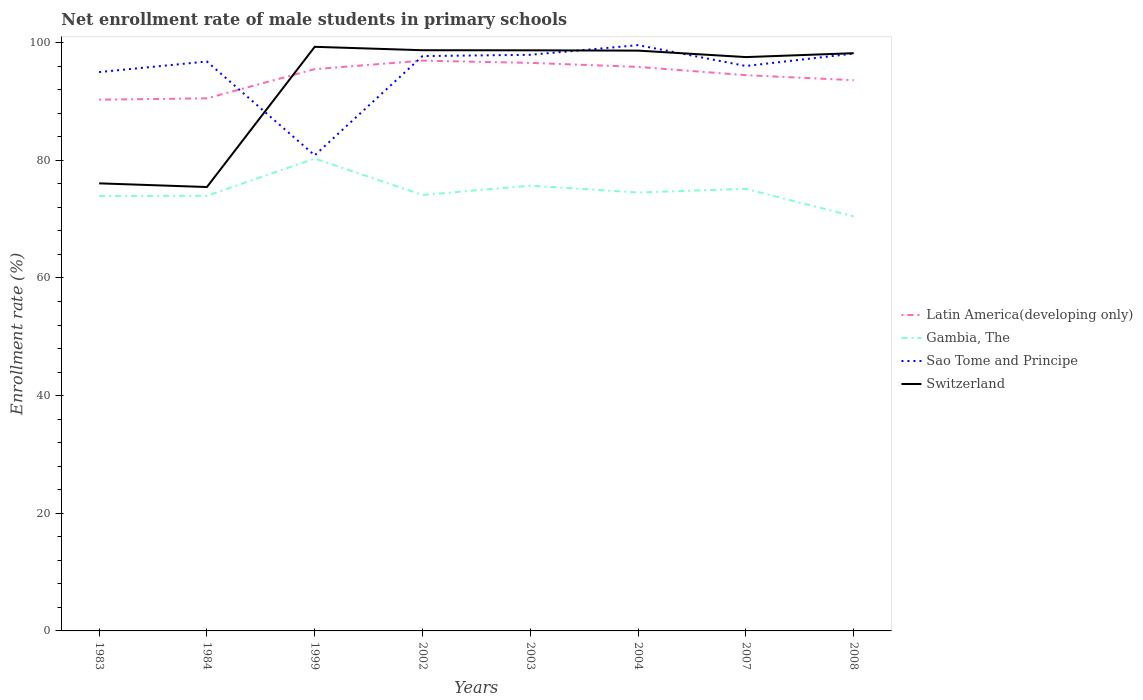Across all years, what is the maximum net enrollment rate of male students in primary schools in Switzerland?
Your response must be concise. 75.45. In which year was the net enrollment rate of male students in primary schools in Latin America(developing only) maximum?
Make the answer very short. 1983. What is the total net enrollment rate of male students in primary schools in Switzerland in the graph?
Give a very brief answer. 0.05. What is the difference between the highest and the second highest net enrollment rate of male students in primary schools in Gambia, The?
Ensure brevity in your answer.  9.83. Is the net enrollment rate of male students in primary schools in Gambia, The strictly greater than the net enrollment rate of male students in primary schools in Switzerland over the years?
Give a very brief answer. Yes. How many years are there in the graph?
Offer a very short reply. 8. Are the values on the major ticks of Y-axis written in scientific E-notation?
Ensure brevity in your answer.  No. How are the legend labels stacked?
Your answer should be compact. Vertical. What is the title of the graph?
Ensure brevity in your answer.  Net enrollment rate of male students in primary schools. What is the label or title of the Y-axis?
Offer a very short reply. Enrollment rate (%). What is the Enrollment rate (%) of Latin America(developing only) in 1983?
Your answer should be very brief. 90.3. What is the Enrollment rate (%) in Gambia, The in 1983?
Provide a short and direct response. 73.94. What is the Enrollment rate (%) in Sao Tome and Principe in 1983?
Provide a short and direct response. 94.99. What is the Enrollment rate (%) of Switzerland in 1983?
Your response must be concise. 76.08. What is the Enrollment rate (%) of Latin America(developing only) in 1984?
Offer a terse response. 90.53. What is the Enrollment rate (%) of Gambia, The in 1984?
Give a very brief answer. 73.97. What is the Enrollment rate (%) in Sao Tome and Principe in 1984?
Ensure brevity in your answer.  96.79. What is the Enrollment rate (%) of Switzerland in 1984?
Provide a succinct answer. 75.45. What is the Enrollment rate (%) in Latin America(developing only) in 1999?
Keep it short and to the point. 95.5. What is the Enrollment rate (%) of Gambia, The in 1999?
Your answer should be compact. 80.3. What is the Enrollment rate (%) of Sao Tome and Principe in 1999?
Offer a terse response. 80.84. What is the Enrollment rate (%) in Switzerland in 1999?
Provide a succinct answer. 99.29. What is the Enrollment rate (%) of Latin America(developing only) in 2002?
Keep it short and to the point. 96.94. What is the Enrollment rate (%) of Gambia, The in 2002?
Your answer should be very brief. 74.1. What is the Enrollment rate (%) in Sao Tome and Principe in 2002?
Offer a very short reply. 97.72. What is the Enrollment rate (%) of Switzerland in 2002?
Offer a terse response. 98.71. What is the Enrollment rate (%) of Latin America(developing only) in 2003?
Make the answer very short. 96.56. What is the Enrollment rate (%) of Gambia, The in 2003?
Your response must be concise. 75.69. What is the Enrollment rate (%) in Sao Tome and Principe in 2003?
Give a very brief answer. 97.93. What is the Enrollment rate (%) in Switzerland in 2003?
Offer a terse response. 98.69. What is the Enrollment rate (%) in Latin America(developing only) in 2004?
Provide a short and direct response. 95.88. What is the Enrollment rate (%) in Gambia, The in 2004?
Offer a very short reply. 74.53. What is the Enrollment rate (%) in Sao Tome and Principe in 2004?
Provide a short and direct response. 99.57. What is the Enrollment rate (%) of Switzerland in 2004?
Offer a very short reply. 98.64. What is the Enrollment rate (%) of Latin America(developing only) in 2007?
Provide a short and direct response. 94.47. What is the Enrollment rate (%) of Gambia, The in 2007?
Keep it short and to the point. 75.15. What is the Enrollment rate (%) of Sao Tome and Principe in 2007?
Provide a short and direct response. 96.03. What is the Enrollment rate (%) of Switzerland in 2007?
Offer a very short reply. 97.54. What is the Enrollment rate (%) of Latin America(developing only) in 2008?
Offer a terse response. 93.62. What is the Enrollment rate (%) of Gambia, The in 2008?
Offer a terse response. 70.47. What is the Enrollment rate (%) of Sao Tome and Principe in 2008?
Ensure brevity in your answer.  98.14. What is the Enrollment rate (%) of Switzerland in 2008?
Ensure brevity in your answer.  98.2. Across all years, what is the maximum Enrollment rate (%) of Latin America(developing only)?
Offer a very short reply. 96.94. Across all years, what is the maximum Enrollment rate (%) of Gambia, The?
Your response must be concise. 80.3. Across all years, what is the maximum Enrollment rate (%) in Sao Tome and Principe?
Ensure brevity in your answer.  99.57. Across all years, what is the maximum Enrollment rate (%) in Switzerland?
Offer a very short reply. 99.29. Across all years, what is the minimum Enrollment rate (%) of Latin America(developing only)?
Your answer should be very brief. 90.3. Across all years, what is the minimum Enrollment rate (%) of Gambia, The?
Your response must be concise. 70.47. Across all years, what is the minimum Enrollment rate (%) of Sao Tome and Principe?
Offer a terse response. 80.84. Across all years, what is the minimum Enrollment rate (%) of Switzerland?
Provide a succinct answer. 75.45. What is the total Enrollment rate (%) of Latin America(developing only) in the graph?
Make the answer very short. 753.78. What is the total Enrollment rate (%) in Gambia, The in the graph?
Your answer should be very brief. 598.14. What is the total Enrollment rate (%) in Sao Tome and Principe in the graph?
Provide a succinct answer. 762.01. What is the total Enrollment rate (%) of Switzerland in the graph?
Make the answer very short. 742.61. What is the difference between the Enrollment rate (%) of Latin America(developing only) in 1983 and that in 1984?
Give a very brief answer. -0.23. What is the difference between the Enrollment rate (%) of Gambia, The in 1983 and that in 1984?
Give a very brief answer. -0.03. What is the difference between the Enrollment rate (%) in Sao Tome and Principe in 1983 and that in 1984?
Give a very brief answer. -1.8. What is the difference between the Enrollment rate (%) of Switzerland in 1983 and that in 1984?
Your response must be concise. 0.63. What is the difference between the Enrollment rate (%) of Latin America(developing only) in 1983 and that in 1999?
Your response must be concise. -5.19. What is the difference between the Enrollment rate (%) in Gambia, The in 1983 and that in 1999?
Ensure brevity in your answer.  -6.36. What is the difference between the Enrollment rate (%) of Sao Tome and Principe in 1983 and that in 1999?
Your response must be concise. 14.15. What is the difference between the Enrollment rate (%) in Switzerland in 1983 and that in 1999?
Provide a succinct answer. -23.21. What is the difference between the Enrollment rate (%) of Latin America(developing only) in 1983 and that in 2002?
Ensure brevity in your answer.  -6.63. What is the difference between the Enrollment rate (%) in Gambia, The in 1983 and that in 2002?
Keep it short and to the point. -0.16. What is the difference between the Enrollment rate (%) of Sao Tome and Principe in 1983 and that in 2002?
Offer a very short reply. -2.72. What is the difference between the Enrollment rate (%) of Switzerland in 1983 and that in 2002?
Provide a succinct answer. -22.63. What is the difference between the Enrollment rate (%) of Latin America(developing only) in 1983 and that in 2003?
Ensure brevity in your answer.  -6.25. What is the difference between the Enrollment rate (%) of Gambia, The in 1983 and that in 2003?
Make the answer very short. -1.75. What is the difference between the Enrollment rate (%) of Sao Tome and Principe in 1983 and that in 2003?
Ensure brevity in your answer.  -2.94. What is the difference between the Enrollment rate (%) of Switzerland in 1983 and that in 2003?
Provide a succinct answer. -22.61. What is the difference between the Enrollment rate (%) of Latin America(developing only) in 1983 and that in 2004?
Offer a very short reply. -5.57. What is the difference between the Enrollment rate (%) in Gambia, The in 1983 and that in 2004?
Offer a terse response. -0.58. What is the difference between the Enrollment rate (%) of Sao Tome and Principe in 1983 and that in 2004?
Provide a short and direct response. -4.58. What is the difference between the Enrollment rate (%) in Switzerland in 1983 and that in 2004?
Give a very brief answer. -22.56. What is the difference between the Enrollment rate (%) of Latin America(developing only) in 1983 and that in 2007?
Offer a very short reply. -4.17. What is the difference between the Enrollment rate (%) in Gambia, The in 1983 and that in 2007?
Provide a succinct answer. -1.21. What is the difference between the Enrollment rate (%) of Sao Tome and Principe in 1983 and that in 2007?
Offer a very short reply. -1.04. What is the difference between the Enrollment rate (%) of Switzerland in 1983 and that in 2007?
Keep it short and to the point. -21.46. What is the difference between the Enrollment rate (%) in Latin America(developing only) in 1983 and that in 2008?
Provide a succinct answer. -3.31. What is the difference between the Enrollment rate (%) in Gambia, The in 1983 and that in 2008?
Make the answer very short. 3.47. What is the difference between the Enrollment rate (%) in Sao Tome and Principe in 1983 and that in 2008?
Your response must be concise. -3.14. What is the difference between the Enrollment rate (%) in Switzerland in 1983 and that in 2008?
Ensure brevity in your answer.  -22.12. What is the difference between the Enrollment rate (%) in Latin America(developing only) in 1984 and that in 1999?
Your answer should be very brief. -4.96. What is the difference between the Enrollment rate (%) of Gambia, The in 1984 and that in 1999?
Your response must be concise. -6.33. What is the difference between the Enrollment rate (%) of Sao Tome and Principe in 1984 and that in 1999?
Give a very brief answer. 15.95. What is the difference between the Enrollment rate (%) in Switzerland in 1984 and that in 1999?
Give a very brief answer. -23.84. What is the difference between the Enrollment rate (%) of Latin America(developing only) in 1984 and that in 2002?
Give a very brief answer. -6.41. What is the difference between the Enrollment rate (%) in Gambia, The in 1984 and that in 2002?
Keep it short and to the point. -0.13. What is the difference between the Enrollment rate (%) in Sao Tome and Principe in 1984 and that in 2002?
Ensure brevity in your answer.  -0.92. What is the difference between the Enrollment rate (%) in Switzerland in 1984 and that in 2002?
Ensure brevity in your answer.  -23.26. What is the difference between the Enrollment rate (%) of Latin America(developing only) in 1984 and that in 2003?
Keep it short and to the point. -6.03. What is the difference between the Enrollment rate (%) in Gambia, The in 1984 and that in 2003?
Give a very brief answer. -1.72. What is the difference between the Enrollment rate (%) in Sao Tome and Principe in 1984 and that in 2003?
Your answer should be very brief. -1.14. What is the difference between the Enrollment rate (%) of Switzerland in 1984 and that in 2003?
Your answer should be compact. -23.24. What is the difference between the Enrollment rate (%) of Latin America(developing only) in 1984 and that in 2004?
Your answer should be compact. -5.34. What is the difference between the Enrollment rate (%) of Gambia, The in 1984 and that in 2004?
Your response must be concise. -0.56. What is the difference between the Enrollment rate (%) of Sao Tome and Principe in 1984 and that in 2004?
Provide a succinct answer. -2.78. What is the difference between the Enrollment rate (%) of Switzerland in 1984 and that in 2004?
Provide a succinct answer. -23.19. What is the difference between the Enrollment rate (%) of Latin America(developing only) in 1984 and that in 2007?
Make the answer very short. -3.94. What is the difference between the Enrollment rate (%) in Gambia, The in 1984 and that in 2007?
Offer a very short reply. -1.18. What is the difference between the Enrollment rate (%) of Sao Tome and Principe in 1984 and that in 2007?
Ensure brevity in your answer.  0.76. What is the difference between the Enrollment rate (%) of Switzerland in 1984 and that in 2007?
Provide a short and direct response. -22.09. What is the difference between the Enrollment rate (%) of Latin America(developing only) in 1984 and that in 2008?
Ensure brevity in your answer.  -3.08. What is the difference between the Enrollment rate (%) in Gambia, The in 1984 and that in 2008?
Ensure brevity in your answer.  3.49. What is the difference between the Enrollment rate (%) in Sao Tome and Principe in 1984 and that in 2008?
Your response must be concise. -1.35. What is the difference between the Enrollment rate (%) of Switzerland in 1984 and that in 2008?
Keep it short and to the point. -22.75. What is the difference between the Enrollment rate (%) of Latin America(developing only) in 1999 and that in 2002?
Provide a short and direct response. -1.44. What is the difference between the Enrollment rate (%) of Gambia, The in 1999 and that in 2002?
Offer a terse response. 6.2. What is the difference between the Enrollment rate (%) in Sao Tome and Principe in 1999 and that in 2002?
Your response must be concise. -16.88. What is the difference between the Enrollment rate (%) of Switzerland in 1999 and that in 2002?
Make the answer very short. 0.58. What is the difference between the Enrollment rate (%) of Latin America(developing only) in 1999 and that in 2003?
Provide a succinct answer. -1.06. What is the difference between the Enrollment rate (%) of Gambia, The in 1999 and that in 2003?
Your answer should be very brief. 4.61. What is the difference between the Enrollment rate (%) in Sao Tome and Principe in 1999 and that in 2003?
Your answer should be very brief. -17.09. What is the difference between the Enrollment rate (%) in Switzerland in 1999 and that in 2003?
Keep it short and to the point. 0.59. What is the difference between the Enrollment rate (%) in Latin America(developing only) in 1999 and that in 2004?
Provide a succinct answer. -0.38. What is the difference between the Enrollment rate (%) of Gambia, The in 1999 and that in 2004?
Make the answer very short. 5.77. What is the difference between the Enrollment rate (%) of Sao Tome and Principe in 1999 and that in 2004?
Provide a succinct answer. -18.74. What is the difference between the Enrollment rate (%) in Switzerland in 1999 and that in 2004?
Provide a short and direct response. 0.65. What is the difference between the Enrollment rate (%) of Latin America(developing only) in 1999 and that in 2007?
Offer a very short reply. 1.03. What is the difference between the Enrollment rate (%) in Gambia, The in 1999 and that in 2007?
Ensure brevity in your answer.  5.15. What is the difference between the Enrollment rate (%) in Sao Tome and Principe in 1999 and that in 2007?
Give a very brief answer. -15.19. What is the difference between the Enrollment rate (%) of Switzerland in 1999 and that in 2007?
Provide a succinct answer. 1.75. What is the difference between the Enrollment rate (%) in Latin America(developing only) in 1999 and that in 2008?
Ensure brevity in your answer.  1.88. What is the difference between the Enrollment rate (%) in Gambia, The in 1999 and that in 2008?
Your answer should be compact. 9.83. What is the difference between the Enrollment rate (%) in Sao Tome and Principe in 1999 and that in 2008?
Ensure brevity in your answer.  -17.3. What is the difference between the Enrollment rate (%) of Switzerland in 1999 and that in 2008?
Provide a succinct answer. 1.08. What is the difference between the Enrollment rate (%) of Latin America(developing only) in 2002 and that in 2003?
Your answer should be very brief. 0.38. What is the difference between the Enrollment rate (%) in Gambia, The in 2002 and that in 2003?
Your answer should be very brief. -1.59. What is the difference between the Enrollment rate (%) in Sao Tome and Principe in 2002 and that in 2003?
Keep it short and to the point. -0.21. What is the difference between the Enrollment rate (%) in Switzerland in 2002 and that in 2003?
Make the answer very short. 0.02. What is the difference between the Enrollment rate (%) in Latin America(developing only) in 2002 and that in 2004?
Your answer should be very brief. 1.06. What is the difference between the Enrollment rate (%) in Gambia, The in 2002 and that in 2004?
Keep it short and to the point. -0.42. What is the difference between the Enrollment rate (%) in Sao Tome and Principe in 2002 and that in 2004?
Provide a succinct answer. -1.86. What is the difference between the Enrollment rate (%) in Switzerland in 2002 and that in 2004?
Your response must be concise. 0.07. What is the difference between the Enrollment rate (%) in Latin America(developing only) in 2002 and that in 2007?
Your answer should be very brief. 2.47. What is the difference between the Enrollment rate (%) in Gambia, The in 2002 and that in 2007?
Provide a short and direct response. -1.04. What is the difference between the Enrollment rate (%) in Sao Tome and Principe in 2002 and that in 2007?
Offer a very short reply. 1.69. What is the difference between the Enrollment rate (%) of Switzerland in 2002 and that in 2007?
Give a very brief answer. 1.17. What is the difference between the Enrollment rate (%) in Latin America(developing only) in 2002 and that in 2008?
Make the answer very short. 3.32. What is the difference between the Enrollment rate (%) of Gambia, The in 2002 and that in 2008?
Make the answer very short. 3.63. What is the difference between the Enrollment rate (%) in Sao Tome and Principe in 2002 and that in 2008?
Your response must be concise. -0.42. What is the difference between the Enrollment rate (%) of Switzerland in 2002 and that in 2008?
Your answer should be compact. 0.51. What is the difference between the Enrollment rate (%) of Latin America(developing only) in 2003 and that in 2004?
Provide a short and direct response. 0.68. What is the difference between the Enrollment rate (%) of Gambia, The in 2003 and that in 2004?
Your answer should be very brief. 1.16. What is the difference between the Enrollment rate (%) of Sao Tome and Principe in 2003 and that in 2004?
Your answer should be compact. -1.64. What is the difference between the Enrollment rate (%) of Switzerland in 2003 and that in 2004?
Your answer should be compact. 0.05. What is the difference between the Enrollment rate (%) of Latin America(developing only) in 2003 and that in 2007?
Offer a very short reply. 2.09. What is the difference between the Enrollment rate (%) in Gambia, The in 2003 and that in 2007?
Your answer should be compact. 0.54. What is the difference between the Enrollment rate (%) of Sao Tome and Principe in 2003 and that in 2007?
Your response must be concise. 1.9. What is the difference between the Enrollment rate (%) in Switzerland in 2003 and that in 2007?
Ensure brevity in your answer.  1.15. What is the difference between the Enrollment rate (%) of Latin America(developing only) in 2003 and that in 2008?
Offer a very short reply. 2.94. What is the difference between the Enrollment rate (%) of Gambia, The in 2003 and that in 2008?
Give a very brief answer. 5.22. What is the difference between the Enrollment rate (%) of Sao Tome and Principe in 2003 and that in 2008?
Make the answer very short. -0.21. What is the difference between the Enrollment rate (%) in Switzerland in 2003 and that in 2008?
Your answer should be compact. 0.49. What is the difference between the Enrollment rate (%) of Latin America(developing only) in 2004 and that in 2007?
Provide a short and direct response. 1.41. What is the difference between the Enrollment rate (%) of Gambia, The in 2004 and that in 2007?
Ensure brevity in your answer.  -0.62. What is the difference between the Enrollment rate (%) in Sao Tome and Principe in 2004 and that in 2007?
Make the answer very short. 3.54. What is the difference between the Enrollment rate (%) in Switzerland in 2004 and that in 2007?
Provide a succinct answer. 1.1. What is the difference between the Enrollment rate (%) in Latin America(developing only) in 2004 and that in 2008?
Keep it short and to the point. 2.26. What is the difference between the Enrollment rate (%) in Gambia, The in 2004 and that in 2008?
Ensure brevity in your answer.  4.05. What is the difference between the Enrollment rate (%) in Sao Tome and Principe in 2004 and that in 2008?
Offer a very short reply. 1.44. What is the difference between the Enrollment rate (%) in Switzerland in 2004 and that in 2008?
Ensure brevity in your answer.  0.44. What is the difference between the Enrollment rate (%) in Latin America(developing only) in 2007 and that in 2008?
Your answer should be very brief. 0.85. What is the difference between the Enrollment rate (%) in Gambia, The in 2007 and that in 2008?
Ensure brevity in your answer.  4.67. What is the difference between the Enrollment rate (%) in Sao Tome and Principe in 2007 and that in 2008?
Make the answer very short. -2.11. What is the difference between the Enrollment rate (%) of Switzerland in 2007 and that in 2008?
Provide a short and direct response. -0.66. What is the difference between the Enrollment rate (%) in Latin America(developing only) in 1983 and the Enrollment rate (%) in Gambia, The in 1984?
Give a very brief answer. 16.34. What is the difference between the Enrollment rate (%) of Latin America(developing only) in 1983 and the Enrollment rate (%) of Sao Tome and Principe in 1984?
Keep it short and to the point. -6.49. What is the difference between the Enrollment rate (%) in Latin America(developing only) in 1983 and the Enrollment rate (%) in Switzerland in 1984?
Keep it short and to the point. 14.85. What is the difference between the Enrollment rate (%) of Gambia, The in 1983 and the Enrollment rate (%) of Sao Tome and Principe in 1984?
Provide a short and direct response. -22.85. What is the difference between the Enrollment rate (%) of Gambia, The in 1983 and the Enrollment rate (%) of Switzerland in 1984?
Your answer should be very brief. -1.51. What is the difference between the Enrollment rate (%) in Sao Tome and Principe in 1983 and the Enrollment rate (%) in Switzerland in 1984?
Offer a very short reply. 19.54. What is the difference between the Enrollment rate (%) in Latin America(developing only) in 1983 and the Enrollment rate (%) in Gambia, The in 1999?
Offer a very short reply. 10. What is the difference between the Enrollment rate (%) in Latin America(developing only) in 1983 and the Enrollment rate (%) in Sao Tome and Principe in 1999?
Offer a very short reply. 9.46. What is the difference between the Enrollment rate (%) of Latin America(developing only) in 1983 and the Enrollment rate (%) of Switzerland in 1999?
Your answer should be very brief. -8.99. What is the difference between the Enrollment rate (%) of Gambia, The in 1983 and the Enrollment rate (%) of Sao Tome and Principe in 1999?
Offer a very short reply. -6.9. What is the difference between the Enrollment rate (%) of Gambia, The in 1983 and the Enrollment rate (%) of Switzerland in 1999?
Your response must be concise. -25.35. What is the difference between the Enrollment rate (%) in Sao Tome and Principe in 1983 and the Enrollment rate (%) in Switzerland in 1999?
Offer a very short reply. -4.3. What is the difference between the Enrollment rate (%) in Latin America(developing only) in 1983 and the Enrollment rate (%) in Gambia, The in 2002?
Your answer should be compact. 16.2. What is the difference between the Enrollment rate (%) in Latin America(developing only) in 1983 and the Enrollment rate (%) in Sao Tome and Principe in 2002?
Your response must be concise. -7.41. What is the difference between the Enrollment rate (%) of Latin America(developing only) in 1983 and the Enrollment rate (%) of Switzerland in 2002?
Provide a short and direct response. -8.41. What is the difference between the Enrollment rate (%) in Gambia, The in 1983 and the Enrollment rate (%) in Sao Tome and Principe in 2002?
Ensure brevity in your answer.  -23.78. What is the difference between the Enrollment rate (%) in Gambia, The in 1983 and the Enrollment rate (%) in Switzerland in 2002?
Provide a short and direct response. -24.77. What is the difference between the Enrollment rate (%) of Sao Tome and Principe in 1983 and the Enrollment rate (%) of Switzerland in 2002?
Your answer should be very brief. -3.72. What is the difference between the Enrollment rate (%) of Latin America(developing only) in 1983 and the Enrollment rate (%) of Gambia, The in 2003?
Your answer should be compact. 14.61. What is the difference between the Enrollment rate (%) in Latin America(developing only) in 1983 and the Enrollment rate (%) in Sao Tome and Principe in 2003?
Your answer should be very brief. -7.63. What is the difference between the Enrollment rate (%) of Latin America(developing only) in 1983 and the Enrollment rate (%) of Switzerland in 2003?
Offer a terse response. -8.39. What is the difference between the Enrollment rate (%) in Gambia, The in 1983 and the Enrollment rate (%) in Sao Tome and Principe in 2003?
Your answer should be very brief. -23.99. What is the difference between the Enrollment rate (%) of Gambia, The in 1983 and the Enrollment rate (%) of Switzerland in 2003?
Your answer should be very brief. -24.75. What is the difference between the Enrollment rate (%) in Sao Tome and Principe in 1983 and the Enrollment rate (%) in Switzerland in 2003?
Your answer should be very brief. -3.7. What is the difference between the Enrollment rate (%) of Latin America(developing only) in 1983 and the Enrollment rate (%) of Gambia, The in 2004?
Your answer should be very brief. 15.78. What is the difference between the Enrollment rate (%) of Latin America(developing only) in 1983 and the Enrollment rate (%) of Sao Tome and Principe in 2004?
Offer a terse response. -9.27. What is the difference between the Enrollment rate (%) in Latin America(developing only) in 1983 and the Enrollment rate (%) in Switzerland in 2004?
Offer a terse response. -8.34. What is the difference between the Enrollment rate (%) of Gambia, The in 1983 and the Enrollment rate (%) of Sao Tome and Principe in 2004?
Keep it short and to the point. -25.63. What is the difference between the Enrollment rate (%) in Gambia, The in 1983 and the Enrollment rate (%) in Switzerland in 2004?
Ensure brevity in your answer.  -24.7. What is the difference between the Enrollment rate (%) in Sao Tome and Principe in 1983 and the Enrollment rate (%) in Switzerland in 2004?
Keep it short and to the point. -3.65. What is the difference between the Enrollment rate (%) of Latin America(developing only) in 1983 and the Enrollment rate (%) of Gambia, The in 2007?
Offer a terse response. 15.16. What is the difference between the Enrollment rate (%) of Latin America(developing only) in 1983 and the Enrollment rate (%) of Sao Tome and Principe in 2007?
Make the answer very short. -5.73. What is the difference between the Enrollment rate (%) in Latin America(developing only) in 1983 and the Enrollment rate (%) in Switzerland in 2007?
Your response must be concise. -7.24. What is the difference between the Enrollment rate (%) of Gambia, The in 1983 and the Enrollment rate (%) of Sao Tome and Principe in 2007?
Provide a short and direct response. -22.09. What is the difference between the Enrollment rate (%) of Gambia, The in 1983 and the Enrollment rate (%) of Switzerland in 2007?
Your response must be concise. -23.6. What is the difference between the Enrollment rate (%) in Sao Tome and Principe in 1983 and the Enrollment rate (%) in Switzerland in 2007?
Offer a terse response. -2.55. What is the difference between the Enrollment rate (%) in Latin America(developing only) in 1983 and the Enrollment rate (%) in Gambia, The in 2008?
Provide a succinct answer. 19.83. What is the difference between the Enrollment rate (%) of Latin America(developing only) in 1983 and the Enrollment rate (%) of Sao Tome and Principe in 2008?
Offer a terse response. -7.83. What is the difference between the Enrollment rate (%) of Latin America(developing only) in 1983 and the Enrollment rate (%) of Switzerland in 2008?
Your answer should be compact. -7.9. What is the difference between the Enrollment rate (%) of Gambia, The in 1983 and the Enrollment rate (%) of Sao Tome and Principe in 2008?
Your answer should be very brief. -24.2. What is the difference between the Enrollment rate (%) in Gambia, The in 1983 and the Enrollment rate (%) in Switzerland in 2008?
Your response must be concise. -24.26. What is the difference between the Enrollment rate (%) in Sao Tome and Principe in 1983 and the Enrollment rate (%) in Switzerland in 2008?
Make the answer very short. -3.21. What is the difference between the Enrollment rate (%) in Latin America(developing only) in 1984 and the Enrollment rate (%) in Gambia, The in 1999?
Your response must be concise. 10.23. What is the difference between the Enrollment rate (%) in Latin America(developing only) in 1984 and the Enrollment rate (%) in Sao Tome and Principe in 1999?
Your answer should be compact. 9.69. What is the difference between the Enrollment rate (%) of Latin America(developing only) in 1984 and the Enrollment rate (%) of Switzerland in 1999?
Make the answer very short. -8.76. What is the difference between the Enrollment rate (%) in Gambia, The in 1984 and the Enrollment rate (%) in Sao Tome and Principe in 1999?
Make the answer very short. -6.87. What is the difference between the Enrollment rate (%) of Gambia, The in 1984 and the Enrollment rate (%) of Switzerland in 1999?
Offer a very short reply. -25.32. What is the difference between the Enrollment rate (%) in Sao Tome and Principe in 1984 and the Enrollment rate (%) in Switzerland in 1999?
Provide a succinct answer. -2.5. What is the difference between the Enrollment rate (%) in Latin America(developing only) in 1984 and the Enrollment rate (%) in Gambia, The in 2002?
Your answer should be compact. 16.43. What is the difference between the Enrollment rate (%) in Latin America(developing only) in 1984 and the Enrollment rate (%) in Sao Tome and Principe in 2002?
Offer a very short reply. -7.19. What is the difference between the Enrollment rate (%) in Latin America(developing only) in 1984 and the Enrollment rate (%) in Switzerland in 2002?
Your response must be concise. -8.18. What is the difference between the Enrollment rate (%) of Gambia, The in 1984 and the Enrollment rate (%) of Sao Tome and Principe in 2002?
Make the answer very short. -23.75. What is the difference between the Enrollment rate (%) of Gambia, The in 1984 and the Enrollment rate (%) of Switzerland in 2002?
Make the answer very short. -24.74. What is the difference between the Enrollment rate (%) in Sao Tome and Principe in 1984 and the Enrollment rate (%) in Switzerland in 2002?
Give a very brief answer. -1.92. What is the difference between the Enrollment rate (%) of Latin America(developing only) in 1984 and the Enrollment rate (%) of Gambia, The in 2003?
Give a very brief answer. 14.84. What is the difference between the Enrollment rate (%) in Latin America(developing only) in 1984 and the Enrollment rate (%) in Sao Tome and Principe in 2003?
Provide a short and direct response. -7.4. What is the difference between the Enrollment rate (%) of Latin America(developing only) in 1984 and the Enrollment rate (%) of Switzerland in 2003?
Offer a terse response. -8.16. What is the difference between the Enrollment rate (%) of Gambia, The in 1984 and the Enrollment rate (%) of Sao Tome and Principe in 2003?
Offer a terse response. -23.96. What is the difference between the Enrollment rate (%) in Gambia, The in 1984 and the Enrollment rate (%) in Switzerland in 2003?
Offer a very short reply. -24.73. What is the difference between the Enrollment rate (%) in Sao Tome and Principe in 1984 and the Enrollment rate (%) in Switzerland in 2003?
Ensure brevity in your answer.  -1.9. What is the difference between the Enrollment rate (%) in Latin America(developing only) in 1984 and the Enrollment rate (%) in Gambia, The in 2004?
Your answer should be very brief. 16.01. What is the difference between the Enrollment rate (%) of Latin America(developing only) in 1984 and the Enrollment rate (%) of Sao Tome and Principe in 2004?
Give a very brief answer. -9.04. What is the difference between the Enrollment rate (%) in Latin America(developing only) in 1984 and the Enrollment rate (%) in Switzerland in 2004?
Make the answer very short. -8.11. What is the difference between the Enrollment rate (%) in Gambia, The in 1984 and the Enrollment rate (%) in Sao Tome and Principe in 2004?
Your answer should be compact. -25.61. What is the difference between the Enrollment rate (%) of Gambia, The in 1984 and the Enrollment rate (%) of Switzerland in 2004?
Your answer should be very brief. -24.67. What is the difference between the Enrollment rate (%) in Sao Tome and Principe in 1984 and the Enrollment rate (%) in Switzerland in 2004?
Ensure brevity in your answer.  -1.85. What is the difference between the Enrollment rate (%) of Latin America(developing only) in 1984 and the Enrollment rate (%) of Gambia, The in 2007?
Keep it short and to the point. 15.38. What is the difference between the Enrollment rate (%) in Latin America(developing only) in 1984 and the Enrollment rate (%) in Sao Tome and Principe in 2007?
Offer a very short reply. -5.5. What is the difference between the Enrollment rate (%) in Latin America(developing only) in 1984 and the Enrollment rate (%) in Switzerland in 2007?
Offer a very short reply. -7.01. What is the difference between the Enrollment rate (%) of Gambia, The in 1984 and the Enrollment rate (%) of Sao Tome and Principe in 2007?
Keep it short and to the point. -22.06. What is the difference between the Enrollment rate (%) of Gambia, The in 1984 and the Enrollment rate (%) of Switzerland in 2007?
Give a very brief answer. -23.58. What is the difference between the Enrollment rate (%) of Sao Tome and Principe in 1984 and the Enrollment rate (%) of Switzerland in 2007?
Your response must be concise. -0.75. What is the difference between the Enrollment rate (%) in Latin America(developing only) in 1984 and the Enrollment rate (%) in Gambia, The in 2008?
Give a very brief answer. 20.06. What is the difference between the Enrollment rate (%) of Latin America(developing only) in 1984 and the Enrollment rate (%) of Sao Tome and Principe in 2008?
Make the answer very short. -7.61. What is the difference between the Enrollment rate (%) in Latin America(developing only) in 1984 and the Enrollment rate (%) in Switzerland in 2008?
Give a very brief answer. -7.67. What is the difference between the Enrollment rate (%) of Gambia, The in 1984 and the Enrollment rate (%) of Sao Tome and Principe in 2008?
Keep it short and to the point. -24.17. What is the difference between the Enrollment rate (%) in Gambia, The in 1984 and the Enrollment rate (%) in Switzerland in 2008?
Keep it short and to the point. -24.24. What is the difference between the Enrollment rate (%) in Sao Tome and Principe in 1984 and the Enrollment rate (%) in Switzerland in 2008?
Your answer should be compact. -1.41. What is the difference between the Enrollment rate (%) in Latin America(developing only) in 1999 and the Enrollment rate (%) in Gambia, The in 2002?
Offer a terse response. 21.39. What is the difference between the Enrollment rate (%) in Latin America(developing only) in 1999 and the Enrollment rate (%) in Sao Tome and Principe in 2002?
Your response must be concise. -2.22. What is the difference between the Enrollment rate (%) of Latin America(developing only) in 1999 and the Enrollment rate (%) of Switzerland in 2002?
Provide a short and direct response. -3.22. What is the difference between the Enrollment rate (%) in Gambia, The in 1999 and the Enrollment rate (%) in Sao Tome and Principe in 2002?
Offer a very short reply. -17.42. What is the difference between the Enrollment rate (%) of Gambia, The in 1999 and the Enrollment rate (%) of Switzerland in 2002?
Your answer should be compact. -18.41. What is the difference between the Enrollment rate (%) in Sao Tome and Principe in 1999 and the Enrollment rate (%) in Switzerland in 2002?
Your response must be concise. -17.87. What is the difference between the Enrollment rate (%) of Latin America(developing only) in 1999 and the Enrollment rate (%) of Gambia, The in 2003?
Your response must be concise. 19.8. What is the difference between the Enrollment rate (%) of Latin America(developing only) in 1999 and the Enrollment rate (%) of Sao Tome and Principe in 2003?
Provide a succinct answer. -2.44. What is the difference between the Enrollment rate (%) of Latin America(developing only) in 1999 and the Enrollment rate (%) of Switzerland in 2003?
Offer a terse response. -3.2. What is the difference between the Enrollment rate (%) of Gambia, The in 1999 and the Enrollment rate (%) of Sao Tome and Principe in 2003?
Your answer should be very brief. -17.63. What is the difference between the Enrollment rate (%) in Gambia, The in 1999 and the Enrollment rate (%) in Switzerland in 2003?
Provide a succinct answer. -18.39. What is the difference between the Enrollment rate (%) in Sao Tome and Principe in 1999 and the Enrollment rate (%) in Switzerland in 2003?
Your answer should be very brief. -17.86. What is the difference between the Enrollment rate (%) of Latin America(developing only) in 1999 and the Enrollment rate (%) of Gambia, The in 2004?
Make the answer very short. 20.97. What is the difference between the Enrollment rate (%) of Latin America(developing only) in 1999 and the Enrollment rate (%) of Sao Tome and Principe in 2004?
Keep it short and to the point. -4.08. What is the difference between the Enrollment rate (%) of Latin America(developing only) in 1999 and the Enrollment rate (%) of Switzerland in 2004?
Your response must be concise. -3.15. What is the difference between the Enrollment rate (%) of Gambia, The in 1999 and the Enrollment rate (%) of Sao Tome and Principe in 2004?
Ensure brevity in your answer.  -19.27. What is the difference between the Enrollment rate (%) in Gambia, The in 1999 and the Enrollment rate (%) in Switzerland in 2004?
Offer a terse response. -18.34. What is the difference between the Enrollment rate (%) in Sao Tome and Principe in 1999 and the Enrollment rate (%) in Switzerland in 2004?
Offer a terse response. -17.8. What is the difference between the Enrollment rate (%) of Latin America(developing only) in 1999 and the Enrollment rate (%) of Gambia, The in 2007?
Offer a terse response. 20.35. What is the difference between the Enrollment rate (%) of Latin America(developing only) in 1999 and the Enrollment rate (%) of Sao Tome and Principe in 2007?
Ensure brevity in your answer.  -0.53. What is the difference between the Enrollment rate (%) of Latin America(developing only) in 1999 and the Enrollment rate (%) of Switzerland in 2007?
Make the answer very short. -2.05. What is the difference between the Enrollment rate (%) in Gambia, The in 1999 and the Enrollment rate (%) in Sao Tome and Principe in 2007?
Offer a very short reply. -15.73. What is the difference between the Enrollment rate (%) of Gambia, The in 1999 and the Enrollment rate (%) of Switzerland in 2007?
Your response must be concise. -17.24. What is the difference between the Enrollment rate (%) in Sao Tome and Principe in 1999 and the Enrollment rate (%) in Switzerland in 2007?
Provide a succinct answer. -16.7. What is the difference between the Enrollment rate (%) in Latin America(developing only) in 1999 and the Enrollment rate (%) in Gambia, The in 2008?
Your answer should be very brief. 25.02. What is the difference between the Enrollment rate (%) of Latin America(developing only) in 1999 and the Enrollment rate (%) of Sao Tome and Principe in 2008?
Offer a very short reply. -2.64. What is the difference between the Enrollment rate (%) of Latin America(developing only) in 1999 and the Enrollment rate (%) of Switzerland in 2008?
Provide a short and direct response. -2.71. What is the difference between the Enrollment rate (%) of Gambia, The in 1999 and the Enrollment rate (%) of Sao Tome and Principe in 2008?
Your response must be concise. -17.84. What is the difference between the Enrollment rate (%) in Gambia, The in 1999 and the Enrollment rate (%) in Switzerland in 2008?
Give a very brief answer. -17.91. What is the difference between the Enrollment rate (%) of Sao Tome and Principe in 1999 and the Enrollment rate (%) of Switzerland in 2008?
Offer a terse response. -17.37. What is the difference between the Enrollment rate (%) in Latin America(developing only) in 2002 and the Enrollment rate (%) in Gambia, The in 2003?
Offer a very short reply. 21.25. What is the difference between the Enrollment rate (%) of Latin America(developing only) in 2002 and the Enrollment rate (%) of Sao Tome and Principe in 2003?
Your response must be concise. -0.99. What is the difference between the Enrollment rate (%) of Latin America(developing only) in 2002 and the Enrollment rate (%) of Switzerland in 2003?
Provide a short and direct response. -1.76. What is the difference between the Enrollment rate (%) of Gambia, The in 2002 and the Enrollment rate (%) of Sao Tome and Principe in 2003?
Your answer should be compact. -23.83. What is the difference between the Enrollment rate (%) of Gambia, The in 2002 and the Enrollment rate (%) of Switzerland in 2003?
Your answer should be compact. -24.59. What is the difference between the Enrollment rate (%) of Sao Tome and Principe in 2002 and the Enrollment rate (%) of Switzerland in 2003?
Offer a terse response. -0.98. What is the difference between the Enrollment rate (%) in Latin America(developing only) in 2002 and the Enrollment rate (%) in Gambia, The in 2004?
Offer a very short reply. 22.41. What is the difference between the Enrollment rate (%) in Latin America(developing only) in 2002 and the Enrollment rate (%) in Sao Tome and Principe in 2004?
Your answer should be compact. -2.64. What is the difference between the Enrollment rate (%) of Latin America(developing only) in 2002 and the Enrollment rate (%) of Switzerland in 2004?
Ensure brevity in your answer.  -1.7. What is the difference between the Enrollment rate (%) in Gambia, The in 2002 and the Enrollment rate (%) in Sao Tome and Principe in 2004?
Offer a very short reply. -25.47. What is the difference between the Enrollment rate (%) in Gambia, The in 2002 and the Enrollment rate (%) in Switzerland in 2004?
Make the answer very short. -24.54. What is the difference between the Enrollment rate (%) of Sao Tome and Principe in 2002 and the Enrollment rate (%) of Switzerland in 2004?
Ensure brevity in your answer.  -0.92. What is the difference between the Enrollment rate (%) of Latin America(developing only) in 2002 and the Enrollment rate (%) of Gambia, The in 2007?
Provide a succinct answer. 21.79. What is the difference between the Enrollment rate (%) of Latin America(developing only) in 2002 and the Enrollment rate (%) of Sao Tome and Principe in 2007?
Ensure brevity in your answer.  0.91. What is the difference between the Enrollment rate (%) in Latin America(developing only) in 2002 and the Enrollment rate (%) in Switzerland in 2007?
Ensure brevity in your answer.  -0.6. What is the difference between the Enrollment rate (%) in Gambia, The in 2002 and the Enrollment rate (%) in Sao Tome and Principe in 2007?
Ensure brevity in your answer.  -21.93. What is the difference between the Enrollment rate (%) of Gambia, The in 2002 and the Enrollment rate (%) of Switzerland in 2007?
Offer a terse response. -23.44. What is the difference between the Enrollment rate (%) in Sao Tome and Principe in 2002 and the Enrollment rate (%) in Switzerland in 2007?
Ensure brevity in your answer.  0.17. What is the difference between the Enrollment rate (%) in Latin America(developing only) in 2002 and the Enrollment rate (%) in Gambia, The in 2008?
Ensure brevity in your answer.  26.46. What is the difference between the Enrollment rate (%) of Latin America(developing only) in 2002 and the Enrollment rate (%) of Sao Tome and Principe in 2008?
Provide a succinct answer. -1.2. What is the difference between the Enrollment rate (%) in Latin America(developing only) in 2002 and the Enrollment rate (%) in Switzerland in 2008?
Offer a terse response. -1.27. What is the difference between the Enrollment rate (%) of Gambia, The in 2002 and the Enrollment rate (%) of Sao Tome and Principe in 2008?
Give a very brief answer. -24.04. What is the difference between the Enrollment rate (%) of Gambia, The in 2002 and the Enrollment rate (%) of Switzerland in 2008?
Offer a terse response. -24.1. What is the difference between the Enrollment rate (%) of Sao Tome and Principe in 2002 and the Enrollment rate (%) of Switzerland in 2008?
Provide a succinct answer. -0.49. What is the difference between the Enrollment rate (%) in Latin America(developing only) in 2003 and the Enrollment rate (%) in Gambia, The in 2004?
Provide a succinct answer. 22.03. What is the difference between the Enrollment rate (%) in Latin America(developing only) in 2003 and the Enrollment rate (%) in Sao Tome and Principe in 2004?
Your answer should be very brief. -3.02. What is the difference between the Enrollment rate (%) of Latin America(developing only) in 2003 and the Enrollment rate (%) of Switzerland in 2004?
Provide a succinct answer. -2.08. What is the difference between the Enrollment rate (%) of Gambia, The in 2003 and the Enrollment rate (%) of Sao Tome and Principe in 2004?
Provide a short and direct response. -23.88. What is the difference between the Enrollment rate (%) of Gambia, The in 2003 and the Enrollment rate (%) of Switzerland in 2004?
Provide a short and direct response. -22.95. What is the difference between the Enrollment rate (%) in Sao Tome and Principe in 2003 and the Enrollment rate (%) in Switzerland in 2004?
Keep it short and to the point. -0.71. What is the difference between the Enrollment rate (%) in Latin America(developing only) in 2003 and the Enrollment rate (%) in Gambia, The in 2007?
Provide a short and direct response. 21.41. What is the difference between the Enrollment rate (%) of Latin America(developing only) in 2003 and the Enrollment rate (%) of Sao Tome and Principe in 2007?
Make the answer very short. 0.53. What is the difference between the Enrollment rate (%) in Latin America(developing only) in 2003 and the Enrollment rate (%) in Switzerland in 2007?
Make the answer very short. -0.98. What is the difference between the Enrollment rate (%) of Gambia, The in 2003 and the Enrollment rate (%) of Sao Tome and Principe in 2007?
Provide a succinct answer. -20.34. What is the difference between the Enrollment rate (%) in Gambia, The in 2003 and the Enrollment rate (%) in Switzerland in 2007?
Offer a very short reply. -21.85. What is the difference between the Enrollment rate (%) of Sao Tome and Principe in 2003 and the Enrollment rate (%) of Switzerland in 2007?
Make the answer very short. 0.39. What is the difference between the Enrollment rate (%) in Latin America(developing only) in 2003 and the Enrollment rate (%) in Gambia, The in 2008?
Keep it short and to the point. 26.08. What is the difference between the Enrollment rate (%) in Latin America(developing only) in 2003 and the Enrollment rate (%) in Sao Tome and Principe in 2008?
Provide a succinct answer. -1.58. What is the difference between the Enrollment rate (%) of Latin America(developing only) in 2003 and the Enrollment rate (%) of Switzerland in 2008?
Provide a succinct answer. -1.65. What is the difference between the Enrollment rate (%) of Gambia, The in 2003 and the Enrollment rate (%) of Sao Tome and Principe in 2008?
Offer a very short reply. -22.45. What is the difference between the Enrollment rate (%) of Gambia, The in 2003 and the Enrollment rate (%) of Switzerland in 2008?
Make the answer very short. -22.51. What is the difference between the Enrollment rate (%) in Sao Tome and Principe in 2003 and the Enrollment rate (%) in Switzerland in 2008?
Your answer should be compact. -0.27. What is the difference between the Enrollment rate (%) of Latin America(developing only) in 2004 and the Enrollment rate (%) of Gambia, The in 2007?
Your answer should be compact. 20.73. What is the difference between the Enrollment rate (%) in Latin America(developing only) in 2004 and the Enrollment rate (%) in Sao Tome and Principe in 2007?
Your response must be concise. -0.15. What is the difference between the Enrollment rate (%) in Latin America(developing only) in 2004 and the Enrollment rate (%) in Switzerland in 2007?
Give a very brief answer. -1.67. What is the difference between the Enrollment rate (%) of Gambia, The in 2004 and the Enrollment rate (%) of Sao Tome and Principe in 2007?
Provide a succinct answer. -21.5. What is the difference between the Enrollment rate (%) in Gambia, The in 2004 and the Enrollment rate (%) in Switzerland in 2007?
Ensure brevity in your answer.  -23.02. What is the difference between the Enrollment rate (%) of Sao Tome and Principe in 2004 and the Enrollment rate (%) of Switzerland in 2007?
Your answer should be compact. 2.03. What is the difference between the Enrollment rate (%) of Latin America(developing only) in 2004 and the Enrollment rate (%) of Gambia, The in 2008?
Your answer should be very brief. 25.4. What is the difference between the Enrollment rate (%) of Latin America(developing only) in 2004 and the Enrollment rate (%) of Sao Tome and Principe in 2008?
Offer a very short reply. -2.26. What is the difference between the Enrollment rate (%) of Latin America(developing only) in 2004 and the Enrollment rate (%) of Switzerland in 2008?
Make the answer very short. -2.33. What is the difference between the Enrollment rate (%) of Gambia, The in 2004 and the Enrollment rate (%) of Sao Tome and Principe in 2008?
Provide a succinct answer. -23.61. What is the difference between the Enrollment rate (%) of Gambia, The in 2004 and the Enrollment rate (%) of Switzerland in 2008?
Keep it short and to the point. -23.68. What is the difference between the Enrollment rate (%) in Sao Tome and Principe in 2004 and the Enrollment rate (%) in Switzerland in 2008?
Your response must be concise. 1.37. What is the difference between the Enrollment rate (%) in Latin America(developing only) in 2007 and the Enrollment rate (%) in Gambia, The in 2008?
Your answer should be compact. 23.99. What is the difference between the Enrollment rate (%) of Latin America(developing only) in 2007 and the Enrollment rate (%) of Sao Tome and Principe in 2008?
Your response must be concise. -3.67. What is the difference between the Enrollment rate (%) in Latin America(developing only) in 2007 and the Enrollment rate (%) in Switzerland in 2008?
Provide a succinct answer. -3.74. What is the difference between the Enrollment rate (%) of Gambia, The in 2007 and the Enrollment rate (%) of Sao Tome and Principe in 2008?
Your answer should be compact. -22.99. What is the difference between the Enrollment rate (%) of Gambia, The in 2007 and the Enrollment rate (%) of Switzerland in 2008?
Offer a very short reply. -23.06. What is the difference between the Enrollment rate (%) of Sao Tome and Principe in 2007 and the Enrollment rate (%) of Switzerland in 2008?
Your answer should be very brief. -2.17. What is the average Enrollment rate (%) of Latin America(developing only) per year?
Make the answer very short. 94.22. What is the average Enrollment rate (%) in Gambia, The per year?
Keep it short and to the point. 74.77. What is the average Enrollment rate (%) of Sao Tome and Principe per year?
Your response must be concise. 95.25. What is the average Enrollment rate (%) of Switzerland per year?
Your answer should be very brief. 92.83. In the year 1983, what is the difference between the Enrollment rate (%) of Latin America(developing only) and Enrollment rate (%) of Gambia, The?
Provide a short and direct response. 16.36. In the year 1983, what is the difference between the Enrollment rate (%) in Latin America(developing only) and Enrollment rate (%) in Sao Tome and Principe?
Offer a very short reply. -4.69. In the year 1983, what is the difference between the Enrollment rate (%) of Latin America(developing only) and Enrollment rate (%) of Switzerland?
Provide a succinct answer. 14.22. In the year 1983, what is the difference between the Enrollment rate (%) in Gambia, The and Enrollment rate (%) in Sao Tome and Principe?
Make the answer very short. -21.05. In the year 1983, what is the difference between the Enrollment rate (%) in Gambia, The and Enrollment rate (%) in Switzerland?
Provide a short and direct response. -2.14. In the year 1983, what is the difference between the Enrollment rate (%) of Sao Tome and Principe and Enrollment rate (%) of Switzerland?
Make the answer very short. 18.91. In the year 1984, what is the difference between the Enrollment rate (%) in Latin America(developing only) and Enrollment rate (%) in Gambia, The?
Give a very brief answer. 16.56. In the year 1984, what is the difference between the Enrollment rate (%) in Latin America(developing only) and Enrollment rate (%) in Sao Tome and Principe?
Offer a very short reply. -6.26. In the year 1984, what is the difference between the Enrollment rate (%) of Latin America(developing only) and Enrollment rate (%) of Switzerland?
Make the answer very short. 15.08. In the year 1984, what is the difference between the Enrollment rate (%) in Gambia, The and Enrollment rate (%) in Sao Tome and Principe?
Your answer should be very brief. -22.83. In the year 1984, what is the difference between the Enrollment rate (%) of Gambia, The and Enrollment rate (%) of Switzerland?
Make the answer very short. -1.49. In the year 1984, what is the difference between the Enrollment rate (%) of Sao Tome and Principe and Enrollment rate (%) of Switzerland?
Keep it short and to the point. 21.34. In the year 1999, what is the difference between the Enrollment rate (%) in Latin America(developing only) and Enrollment rate (%) in Gambia, The?
Make the answer very short. 15.2. In the year 1999, what is the difference between the Enrollment rate (%) of Latin America(developing only) and Enrollment rate (%) of Sao Tome and Principe?
Offer a very short reply. 14.66. In the year 1999, what is the difference between the Enrollment rate (%) of Latin America(developing only) and Enrollment rate (%) of Switzerland?
Provide a succinct answer. -3.79. In the year 1999, what is the difference between the Enrollment rate (%) in Gambia, The and Enrollment rate (%) in Sao Tome and Principe?
Your response must be concise. -0.54. In the year 1999, what is the difference between the Enrollment rate (%) of Gambia, The and Enrollment rate (%) of Switzerland?
Offer a very short reply. -18.99. In the year 1999, what is the difference between the Enrollment rate (%) of Sao Tome and Principe and Enrollment rate (%) of Switzerland?
Provide a short and direct response. -18.45. In the year 2002, what is the difference between the Enrollment rate (%) in Latin America(developing only) and Enrollment rate (%) in Gambia, The?
Ensure brevity in your answer.  22.84. In the year 2002, what is the difference between the Enrollment rate (%) in Latin America(developing only) and Enrollment rate (%) in Sao Tome and Principe?
Keep it short and to the point. -0.78. In the year 2002, what is the difference between the Enrollment rate (%) in Latin America(developing only) and Enrollment rate (%) in Switzerland?
Your response must be concise. -1.77. In the year 2002, what is the difference between the Enrollment rate (%) of Gambia, The and Enrollment rate (%) of Sao Tome and Principe?
Keep it short and to the point. -23.61. In the year 2002, what is the difference between the Enrollment rate (%) in Gambia, The and Enrollment rate (%) in Switzerland?
Your response must be concise. -24.61. In the year 2002, what is the difference between the Enrollment rate (%) in Sao Tome and Principe and Enrollment rate (%) in Switzerland?
Your response must be concise. -0.99. In the year 2003, what is the difference between the Enrollment rate (%) in Latin America(developing only) and Enrollment rate (%) in Gambia, The?
Make the answer very short. 20.87. In the year 2003, what is the difference between the Enrollment rate (%) of Latin America(developing only) and Enrollment rate (%) of Sao Tome and Principe?
Offer a very short reply. -1.37. In the year 2003, what is the difference between the Enrollment rate (%) of Latin America(developing only) and Enrollment rate (%) of Switzerland?
Provide a succinct answer. -2.14. In the year 2003, what is the difference between the Enrollment rate (%) in Gambia, The and Enrollment rate (%) in Sao Tome and Principe?
Your answer should be very brief. -22.24. In the year 2003, what is the difference between the Enrollment rate (%) in Gambia, The and Enrollment rate (%) in Switzerland?
Provide a short and direct response. -23. In the year 2003, what is the difference between the Enrollment rate (%) of Sao Tome and Principe and Enrollment rate (%) of Switzerland?
Provide a short and direct response. -0.76. In the year 2004, what is the difference between the Enrollment rate (%) in Latin America(developing only) and Enrollment rate (%) in Gambia, The?
Give a very brief answer. 21.35. In the year 2004, what is the difference between the Enrollment rate (%) in Latin America(developing only) and Enrollment rate (%) in Sao Tome and Principe?
Your answer should be very brief. -3.7. In the year 2004, what is the difference between the Enrollment rate (%) in Latin America(developing only) and Enrollment rate (%) in Switzerland?
Your answer should be very brief. -2.77. In the year 2004, what is the difference between the Enrollment rate (%) in Gambia, The and Enrollment rate (%) in Sao Tome and Principe?
Provide a succinct answer. -25.05. In the year 2004, what is the difference between the Enrollment rate (%) in Gambia, The and Enrollment rate (%) in Switzerland?
Provide a short and direct response. -24.12. In the year 2004, what is the difference between the Enrollment rate (%) of Sao Tome and Principe and Enrollment rate (%) of Switzerland?
Provide a short and direct response. 0.93. In the year 2007, what is the difference between the Enrollment rate (%) of Latin America(developing only) and Enrollment rate (%) of Gambia, The?
Ensure brevity in your answer.  19.32. In the year 2007, what is the difference between the Enrollment rate (%) in Latin America(developing only) and Enrollment rate (%) in Sao Tome and Principe?
Make the answer very short. -1.56. In the year 2007, what is the difference between the Enrollment rate (%) in Latin America(developing only) and Enrollment rate (%) in Switzerland?
Provide a succinct answer. -3.07. In the year 2007, what is the difference between the Enrollment rate (%) in Gambia, The and Enrollment rate (%) in Sao Tome and Principe?
Your answer should be very brief. -20.88. In the year 2007, what is the difference between the Enrollment rate (%) in Gambia, The and Enrollment rate (%) in Switzerland?
Your response must be concise. -22.4. In the year 2007, what is the difference between the Enrollment rate (%) in Sao Tome and Principe and Enrollment rate (%) in Switzerland?
Provide a short and direct response. -1.51. In the year 2008, what is the difference between the Enrollment rate (%) of Latin America(developing only) and Enrollment rate (%) of Gambia, The?
Give a very brief answer. 23.14. In the year 2008, what is the difference between the Enrollment rate (%) in Latin America(developing only) and Enrollment rate (%) in Sao Tome and Principe?
Offer a very short reply. -4.52. In the year 2008, what is the difference between the Enrollment rate (%) of Latin America(developing only) and Enrollment rate (%) of Switzerland?
Offer a very short reply. -4.59. In the year 2008, what is the difference between the Enrollment rate (%) of Gambia, The and Enrollment rate (%) of Sao Tome and Principe?
Give a very brief answer. -27.66. In the year 2008, what is the difference between the Enrollment rate (%) of Gambia, The and Enrollment rate (%) of Switzerland?
Keep it short and to the point. -27.73. In the year 2008, what is the difference between the Enrollment rate (%) in Sao Tome and Principe and Enrollment rate (%) in Switzerland?
Make the answer very short. -0.07. What is the ratio of the Enrollment rate (%) in Latin America(developing only) in 1983 to that in 1984?
Your response must be concise. 1. What is the ratio of the Enrollment rate (%) in Sao Tome and Principe in 1983 to that in 1984?
Your answer should be compact. 0.98. What is the ratio of the Enrollment rate (%) in Switzerland in 1983 to that in 1984?
Your response must be concise. 1.01. What is the ratio of the Enrollment rate (%) of Latin America(developing only) in 1983 to that in 1999?
Make the answer very short. 0.95. What is the ratio of the Enrollment rate (%) in Gambia, The in 1983 to that in 1999?
Your answer should be very brief. 0.92. What is the ratio of the Enrollment rate (%) of Sao Tome and Principe in 1983 to that in 1999?
Provide a short and direct response. 1.18. What is the ratio of the Enrollment rate (%) of Switzerland in 1983 to that in 1999?
Ensure brevity in your answer.  0.77. What is the ratio of the Enrollment rate (%) of Latin America(developing only) in 1983 to that in 2002?
Provide a succinct answer. 0.93. What is the ratio of the Enrollment rate (%) of Gambia, The in 1983 to that in 2002?
Your response must be concise. 1. What is the ratio of the Enrollment rate (%) in Sao Tome and Principe in 1983 to that in 2002?
Make the answer very short. 0.97. What is the ratio of the Enrollment rate (%) in Switzerland in 1983 to that in 2002?
Your answer should be very brief. 0.77. What is the ratio of the Enrollment rate (%) of Latin America(developing only) in 1983 to that in 2003?
Your response must be concise. 0.94. What is the ratio of the Enrollment rate (%) in Gambia, The in 1983 to that in 2003?
Give a very brief answer. 0.98. What is the ratio of the Enrollment rate (%) in Sao Tome and Principe in 1983 to that in 2003?
Make the answer very short. 0.97. What is the ratio of the Enrollment rate (%) of Switzerland in 1983 to that in 2003?
Ensure brevity in your answer.  0.77. What is the ratio of the Enrollment rate (%) in Latin America(developing only) in 1983 to that in 2004?
Provide a succinct answer. 0.94. What is the ratio of the Enrollment rate (%) in Gambia, The in 1983 to that in 2004?
Make the answer very short. 0.99. What is the ratio of the Enrollment rate (%) of Sao Tome and Principe in 1983 to that in 2004?
Offer a terse response. 0.95. What is the ratio of the Enrollment rate (%) of Switzerland in 1983 to that in 2004?
Your answer should be compact. 0.77. What is the ratio of the Enrollment rate (%) in Latin America(developing only) in 1983 to that in 2007?
Provide a succinct answer. 0.96. What is the ratio of the Enrollment rate (%) in Sao Tome and Principe in 1983 to that in 2007?
Provide a succinct answer. 0.99. What is the ratio of the Enrollment rate (%) of Switzerland in 1983 to that in 2007?
Make the answer very short. 0.78. What is the ratio of the Enrollment rate (%) in Latin America(developing only) in 1983 to that in 2008?
Make the answer very short. 0.96. What is the ratio of the Enrollment rate (%) of Gambia, The in 1983 to that in 2008?
Provide a short and direct response. 1.05. What is the ratio of the Enrollment rate (%) of Sao Tome and Principe in 1983 to that in 2008?
Your response must be concise. 0.97. What is the ratio of the Enrollment rate (%) in Switzerland in 1983 to that in 2008?
Offer a terse response. 0.77. What is the ratio of the Enrollment rate (%) of Latin America(developing only) in 1984 to that in 1999?
Keep it short and to the point. 0.95. What is the ratio of the Enrollment rate (%) of Gambia, The in 1984 to that in 1999?
Offer a terse response. 0.92. What is the ratio of the Enrollment rate (%) of Sao Tome and Principe in 1984 to that in 1999?
Provide a short and direct response. 1.2. What is the ratio of the Enrollment rate (%) of Switzerland in 1984 to that in 1999?
Your answer should be compact. 0.76. What is the ratio of the Enrollment rate (%) of Latin America(developing only) in 1984 to that in 2002?
Keep it short and to the point. 0.93. What is the ratio of the Enrollment rate (%) of Gambia, The in 1984 to that in 2002?
Keep it short and to the point. 1. What is the ratio of the Enrollment rate (%) in Switzerland in 1984 to that in 2002?
Your response must be concise. 0.76. What is the ratio of the Enrollment rate (%) in Latin America(developing only) in 1984 to that in 2003?
Provide a short and direct response. 0.94. What is the ratio of the Enrollment rate (%) in Gambia, The in 1984 to that in 2003?
Keep it short and to the point. 0.98. What is the ratio of the Enrollment rate (%) in Sao Tome and Principe in 1984 to that in 2003?
Give a very brief answer. 0.99. What is the ratio of the Enrollment rate (%) in Switzerland in 1984 to that in 2003?
Give a very brief answer. 0.76. What is the ratio of the Enrollment rate (%) in Latin America(developing only) in 1984 to that in 2004?
Provide a succinct answer. 0.94. What is the ratio of the Enrollment rate (%) of Gambia, The in 1984 to that in 2004?
Your answer should be compact. 0.99. What is the ratio of the Enrollment rate (%) of Sao Tome and Principe in 1984 to that in 2004?
Make the answer very short. 0.97. What is the ratio of the Enrollment rate (%) of Switzerland in 1984 to that in 2004?
Provide a succinct answer. 0.76. What is the ratio of the Enrollment rate (%) of Latin America(developing only) in 1984 to that in 2007?
Keep it short and to the point. 0.96. What is the ratio of the Enrollment rate (%) in Gambia, The in 1984 to that in 2007?
Provide a short and direct response. 0.98. What is the ratio of the Enrollment rate (%) in Sao Tome and Principe in 1984 to that in 2007?
Provide a short and direct response. 1.01. What is the ratio of the Enrollment rate (%) of Switzerland in 1984 to that in 2007?
Ensure brevity in your answer.  0.77. What is the ratio of the Enrollment rate (%) in Latin America(developing only) in 1984 to that in 2008?
Offer a very short reply. 0.97. What is the ratio of the Enrollment rate (%) in Gambia, The in 1984 to that in 2008?
Your answer should be compact. 1.05. What is the ratio of the Enrollment rate (%) of Sao Tome and Principe in 1984 to that in 2008?
Offer a terse response. 0.99. What is the ratio of the Enrollment rate (%) of Switzerland in 1984 to that in 2008?
Offer a terse response. 0.77. What is the ratio of the Enrollment rate (%) in Latin America(developing only) in 1999 to that in 2002?
Give a very brief answer. 0.99. What is the ratio of the Enrollment rate (%) of Gambia, The in 1999 to that in 2002?
Your answer should be very brief. 1.08. What is the ratio of the Enrollment rate (%) in Sao Tome and Principe in 1999 to that in 2002?
Your response must be concise. 0.83. What is the ratio of the Enrollment rate (%) of Switzerland in 1999 to that in 2002?
Your response must be concise. 1.01. What is the ratio of the Enrollment rate (%) of Latin America(developing only) in 1999 to that in 2003?
Give a very brief answer. 0.99. What is the ratio of the Enrollment rate (%) of Gambia, The in 1999 to that in 2003?
Offer a very short reply. 1.06. What is the ratio of the Enrollment rate (%) of Sao Tome and Principe in 1999 to that in 2003?
Your answer should be compact. 0.83. What is the ratio of the Enrollment rate (%) of Latin America(developing only) in 1999 to that in 2004?
Offer a terse response. 1. What is the ratio of the Enrollment rate (%) in Gambia, The in 1999 to that in 2004?
Make the answer very short. 1.08. What is the ratio of the Enrollment rate (%) in Sao Tome and Principe in 1999 to that in 2004?
Ensure brevity in your answer.  0.81. What is the ratio of the Enrollment rate (%) of Switzerland in 1999 to that in 2004?
Offer a very short reply. 1.01. What is the ratio of the Enrollment rate (%) in Latin America(developing only) in 1999 to that in 2007?
Your answer should be very brief. 1.01. What is the ratio of the Enrollment rate (%) of Gambia, The in 1999 to that in 2007?
Provide a short and direct response. 1.07. What is the ratio of the Enrollment rate (%) of Sao Tome and Principe in 1999 to that in 2007?
Keep it short and to the point. 0.84. What is the ratio of the Enrollment rate (%) in Switzerland in 1999 to that in 2007?
Your answer should be very brief. 1.02. What is the ratio of the Enrollment rate (%) of Latin America(developing only) in 1999 to that in 2008?
Ensure brevity in your answer.  1.02. What is the ratio of the Enrollment rate (%) in Gambia, The in 1999 to that in 2008?
Provide a succinct answer. 1.14. What is the ratio of the Enrollment rate (%) in Sao Tome and Principe in 1999 to that in 2008?
Keep it short and to the point. 0.82. What is the ratio of the Enrollment rate (%) in Latin America(developing only) in 2002 to that in 2003?
Ensure brevity in your answer.  1. What is the ratio of the Enrollment rate (%) of Gambia, The in 2002 to that in 2003?
Offer a very short reply. 0.98. What is the ratio of the Enrollment rate (%) of Sao Tome and Principe in 2002 to that in 2003?
Your response must be concise. 1. What is the ratio of the Enrollment rate (%) in Switzerland in 2002 to that in 2003?
Keep it short and to the point. 1. What is the ratio of the Enrollment rate (%) in Latin America(developing only) in 2002 to that in 2004?
Your answer should be compact. 1.01. What is the ratio of the Enrollment rate (%) of Gambia, The in 2002 to that in 2004?
Offer a terse response. 0.99. What is the ratio of the Enrollment rate (%) in Sao Tome and Principe in 2002 to that in 2004?
Offer a very short reply. 0.98. What is the ratio of the Enrollment rate (%) in Switzerland in 2002 to that in 2004?
Your answer should be very brief. 1. What is the ratio of the Enrollment rate (%) of Latin America(developing only) in 2002 to that in 2007?
Keep it short and to the point. 1.03. What is the ratio of the Enrollment rate (%) in Gambia, The in 2002 to that in 2007?
Your answer should be very brief. 0.99. What is the ratio of the Enrollment rate (%) of Sao Tome and Principe in 2002 to that in 2007?
Give a very brief answer. 1.02. What is the ratio of the Enrollment rate (%) of Latin America(developing only) in 2002 to that in 2008?
Your answer should be very brief. 1.04. What is the ratio of the Enrollment rate (%) in Gambia, The in 2002 to that in 2008?
Keep it short and to the point. 1.05. What is the ratio of the Enrollment rate (%) of Switzerland in 2002 to that in 2008?
Give a very brief answer. 1.01. What is the ratio of the Enrollment rate (%) of Latin America(developing only) in 2003 to that in 2004?
Your response must be concise. 1.01. What is the ratio of the Enrollment rate (%) in Gambia, The in 2003 to that in 2004?
Offer a terse response. 1.02. What is the ratio of the Enrollment rate (%) in Sao Tome and Principe in 2003 to that in 2004?
Provide a short and direct response. 0.98. What is the ratio of the Enrollment rate (%) in Latin America(developing only) in 2003 to that in 2007?
Offer a very short reply. 1.02. What is the ratio of the Enrollment rate (%) of Sao Tome and Principe in 2003 to that in 2007?
Your answer should be very brief. 1.02. What is the ratio of the Enrollment rate (%) of Switzerland in 2003 to that in 2007?
Ensure brevity in your answer.  1.01. What is the ratio of the Enrollment rate (%) of Latin America(developing only) in 2003 to that in 2008?
Your answer should be very brief. 1.03. What is the ratio of the Enrollment rate (%) in Gambia, The in 2003 to that in 2008?
Your answer should be very brief. 1.07. What is the ratio of the Enrollment rate (%) of Switzerland in 2003 to that in 2008?
Give a very brief answer. 1. What is the ratio of the Enrollment rate (%) of Latin America(developing only) in 2004 to that in 2007?
Your answer should be very brief. 1.01. What is the ratio of the Enrollment rate (%) in Sao Tome and Principe in 2004 to that in 2007?
Keep it short and to the point. 1.04. What is the ratio of the Enrollment rate (%) of Switzerland in 2004 to that in 2007?
Offer a terse response. 1.01. What is the ratio of the Enrollment rate (%) in Latin America(developing only) in 2004 to that in 2008?
Offer a terse response. 1.02. What is the ratio of the Enrollment rate (%) in Gambia, The in 2004 to that in 2008?
Your response must be concise. 1.06. What is the ratio of the Enrollment rate (%) of Sao Tome and Principe in 2004 to that in 2008?
Provide a succinct answer. 1.01. What is the ratio of the Enrollment rate (%) in Latin America(developing only) in 2007 to that in 2008?
Your answer should be very brief. 1.01. What is the ratio of the Enrollment rate (%) in Gambia, The in 2007 to that in 2008?
Make the answer very short. 1.07. What is the ratio of the Enrollment rate (%) of Sao Tome and Principe in 2007 to that in 2008?
Offer a terse response. 0.98. What is the difference between the highest and the second highest Enrollment rate (%) of Latin America(developing only)?
Make the answer very short. 0.38. What is the difference between the highest and the second highest Enrollment rate (%) in Gambia, The?
Give a very brief answer. 4.61. What is the difference between the highest and the second highest Enrollment rate (%) in Sao Tome and Principe?
Make the answer very short. 1.44. What is the difference between the highest and the second highest Enrollment rate (%) of Switzerland?
Your answer should be compact. 0.58. What is the difference between the highest and the lowest Enrollment rate (%) of Latin America(developing only)?
Your answer should be very brief. 6.63. What is the difference between the highest and the lowest Enrollment rate (%) in Gambia, The?
Your answer should be very brief. 9.83. What is the difference between the highest and the lowest Enrollment rate (%) in Sao Tome and Principe?
Provide a succinct answer. 18.74. What is the difference between the highest and the lowest Enrollment rate (%) of Switzerland?
Your answer should be very brief. 23.84. 